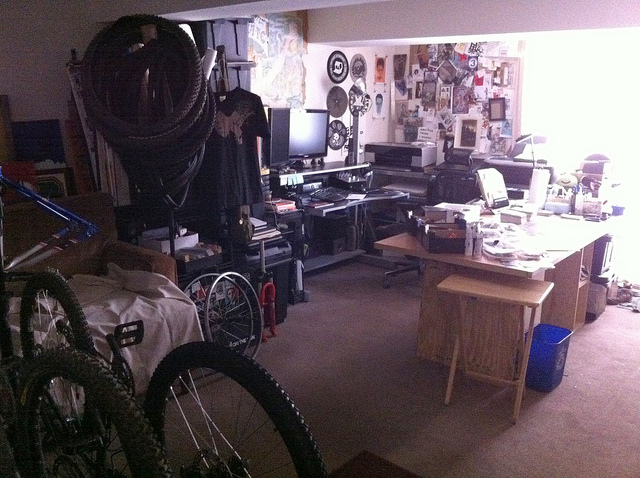Read all the text in this image. &#169; 3 